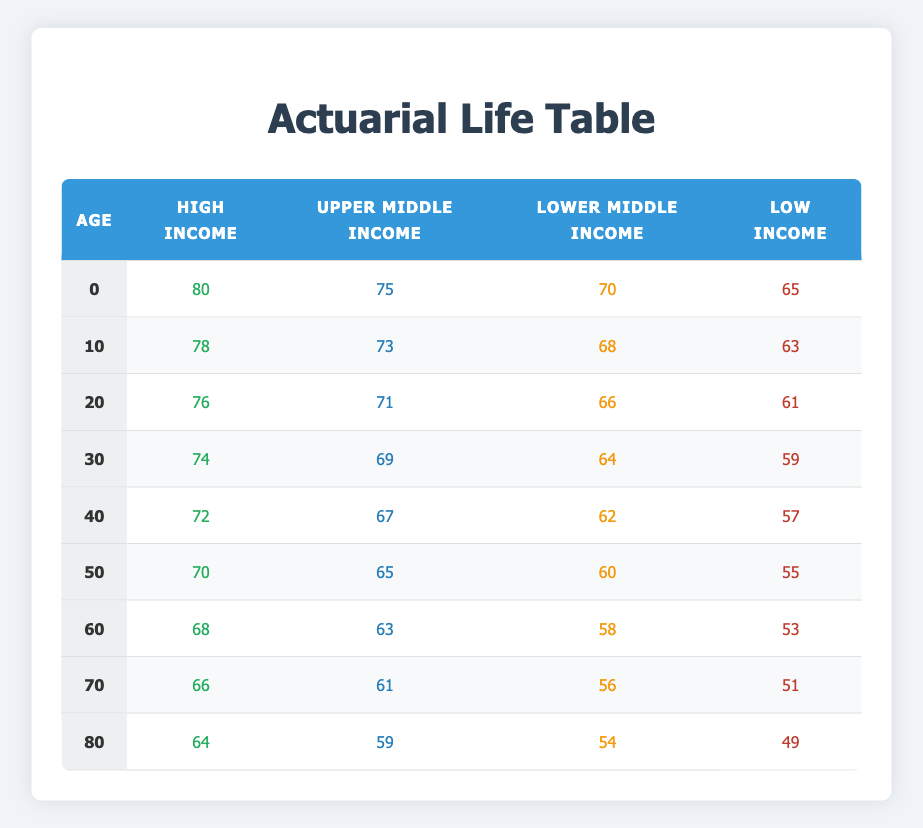What is the life expectancy for a 50-year-old in the Low Income group? The life expectancy for a 50-year-old in the Low Income group is directly listed in the table under the Low Income column for the age of 50, which is 55.
Answer: 55 What is the life expectancy for a 10-year-old in the Upper Middle Income group? The life expectancy for a 10-year-old in the Upper Middle Income group is found in the corresponding age row and column, which is 73.
Answer: 73 Which age group has the highest life expectancy for High Income? The highest life expectancy for the High Income group is found in the 0 age group, which is 80.
Answer: 80 How much higher is the life expectancy for a 30-year-old in the High Income group compared to the Low Income group? For a 30-year-old, the life expectancy for High Income is 74 and for Low Income is 59. The difference is 74 - 59 = 15.
Answer: 15 Is the life expectancy for a 70-year-old in the Lower Middle Income group more than 55? The life expectancy for a 70-year-old in the Lower Middle Income group is found to be 56, which is greater than 55.
Answer: Yes What is the average life expectancy across all socio-economic statuses for a 40-year-old? For a 40-year-old, the life expectancy values are: High Income (72), Upper Middle Income (67), Lower Middle Income (62), Low Income (57). The average is calculated as (72 + 67 + 62 + 57) / 4 = 64.5.
Answer: 64.5 If a person is in the Lower Middle Income group at age 60, what are their chances of living to 70? The life expectancy for the Lower Middle Income group at age 60 is 58 years. This means that a person who is 60 has a life expectancy of 58, which means they may live until age 118 (60 + 58), implying that their chances of living to 70 are high since 70 is within that range.
Answer: Yes What is the median life expectancy for 20-year-olds across all income groups? The life expectancy values for 20-year-olds are: High Income (76), Upper Middle Income (71), Lower Middle Income (66), Low Income (61). Sorting these values gives us: 61, 66, 71, 76. The median is the average of 71 and 66, which is (71 + 66) / 2 = 68.5.
Answer: 68.5 